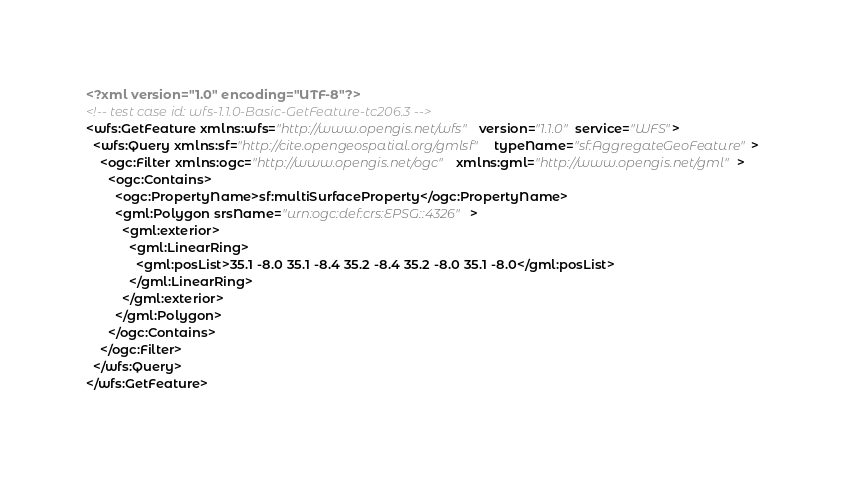<code> <loc_0><loc_0><loc_500><loc_500><_XML_><?xml version="1.0" encoding="UTF-8"?>
<!-- test case id: wfs-1.1.0-Basic-GetFeature-tc206.3 -->
<wfs:GetFeature xmlns:wfs="http://www.opengis.net/wfs" version="1.1.0" service="WFS">
  <wfs:Query xmlns:sf="http://cite.opengeospatial.org/gmlsf" typeName="sf:AggregateGeoFeature">
    <ogc:Filter xmlns:ogc="http://www.opengis.net/ogc" xmlns:gml="http://www.opengis.net/gml">
      <ogc:Contains>
        <ogc:PropertyName>sf:multiSurfaceProperty</ogc:PropertyName>
        <gml:Polygon srsName="urn:ogc:def:crs:EPSG::4326">
          <gml:exterior>
            <gml:LinearRing>
              <gml:posList>35.1 -8.0 35.1 -8.4 35.2 -8.4 35.2 -8.0 35.1 -8.0</gml:posList>
            </gml:LinearRing>
          </gml:exterior>
        </gml:Polygon>
      </ogc:Contains>
    </ogc:Filter>
  </wfs:Query>
</wfs:GetFeature>
</code> 